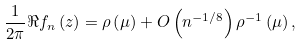Convert formula to latex. <formula><loc_0><loc_0><loc_500><loc_500>\frac { 1 } { 2 \pi } \Re f _ { n } \left ( z \right ) = \rho \left ( \mu \right ) + O \left ( n ^ { - 1 / 8 } \right ) \rho ^ { - 1 } \left ( \mu \right ) ,</formula> 